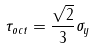<formula> <loc_0><loc_0><loc_500><loc_500>\tau _ { o c t } = \frac { \sqrt { 2 } } { 3 } \sigma _ { y }</formula> 